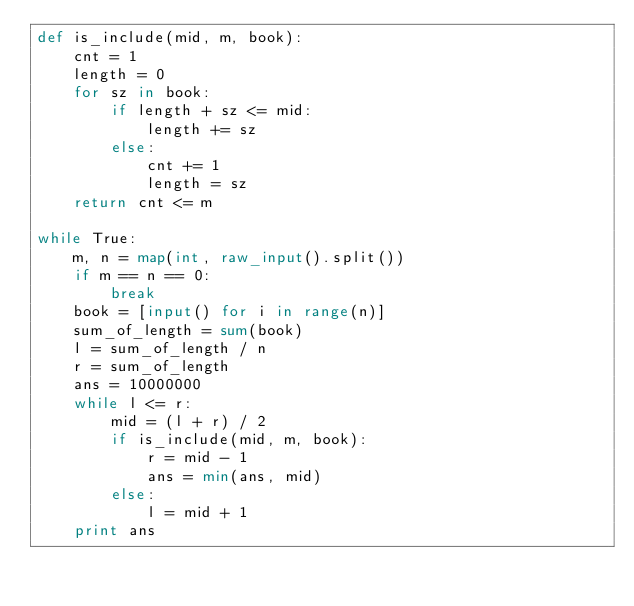Convert code to text. <code><loc_0><loc_0><loc_500><loc_500><_Python_>def is_include(mid, m, book):
    cnt = 1
    length = 0
    for sz in book:
        if length + sz <= mid:
            length += sz
        else:
            cnt += 1
            length = sz
    return cnt <= m

while True:
    m, n = map(int, raw_input().split())
    if m == n == 0:
        break
    book = [input() for i in range(n)]
    sum_of_length = sum(book)
    l = sum_of_length / n
    r = sum_of_length
    ans = 10000000
    while l <= r:
        mid = (l + r) / 2
        if is_include(mid, m, book):
            r = mid - 1
            ans = min(ans, mid)
        else:
            l = mid + 1
    print ans</code> 